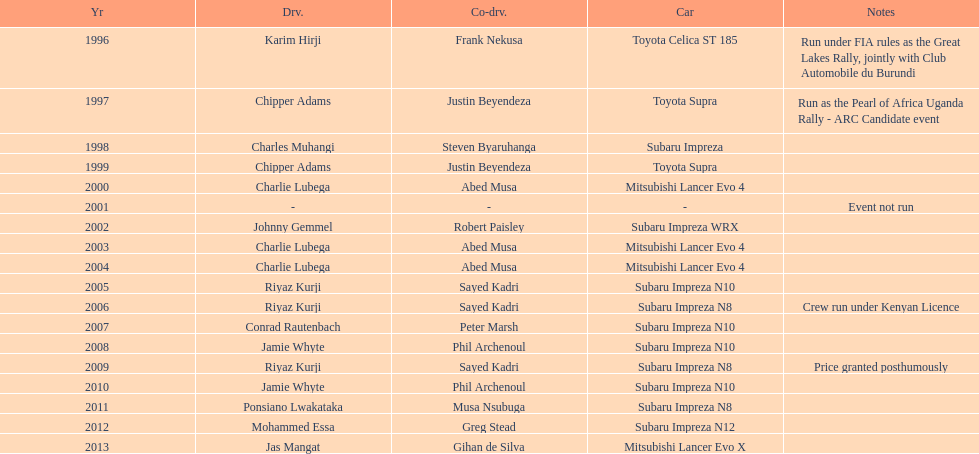How many times was a mitsubishi lancer the winning car before the year 2004? 2. 